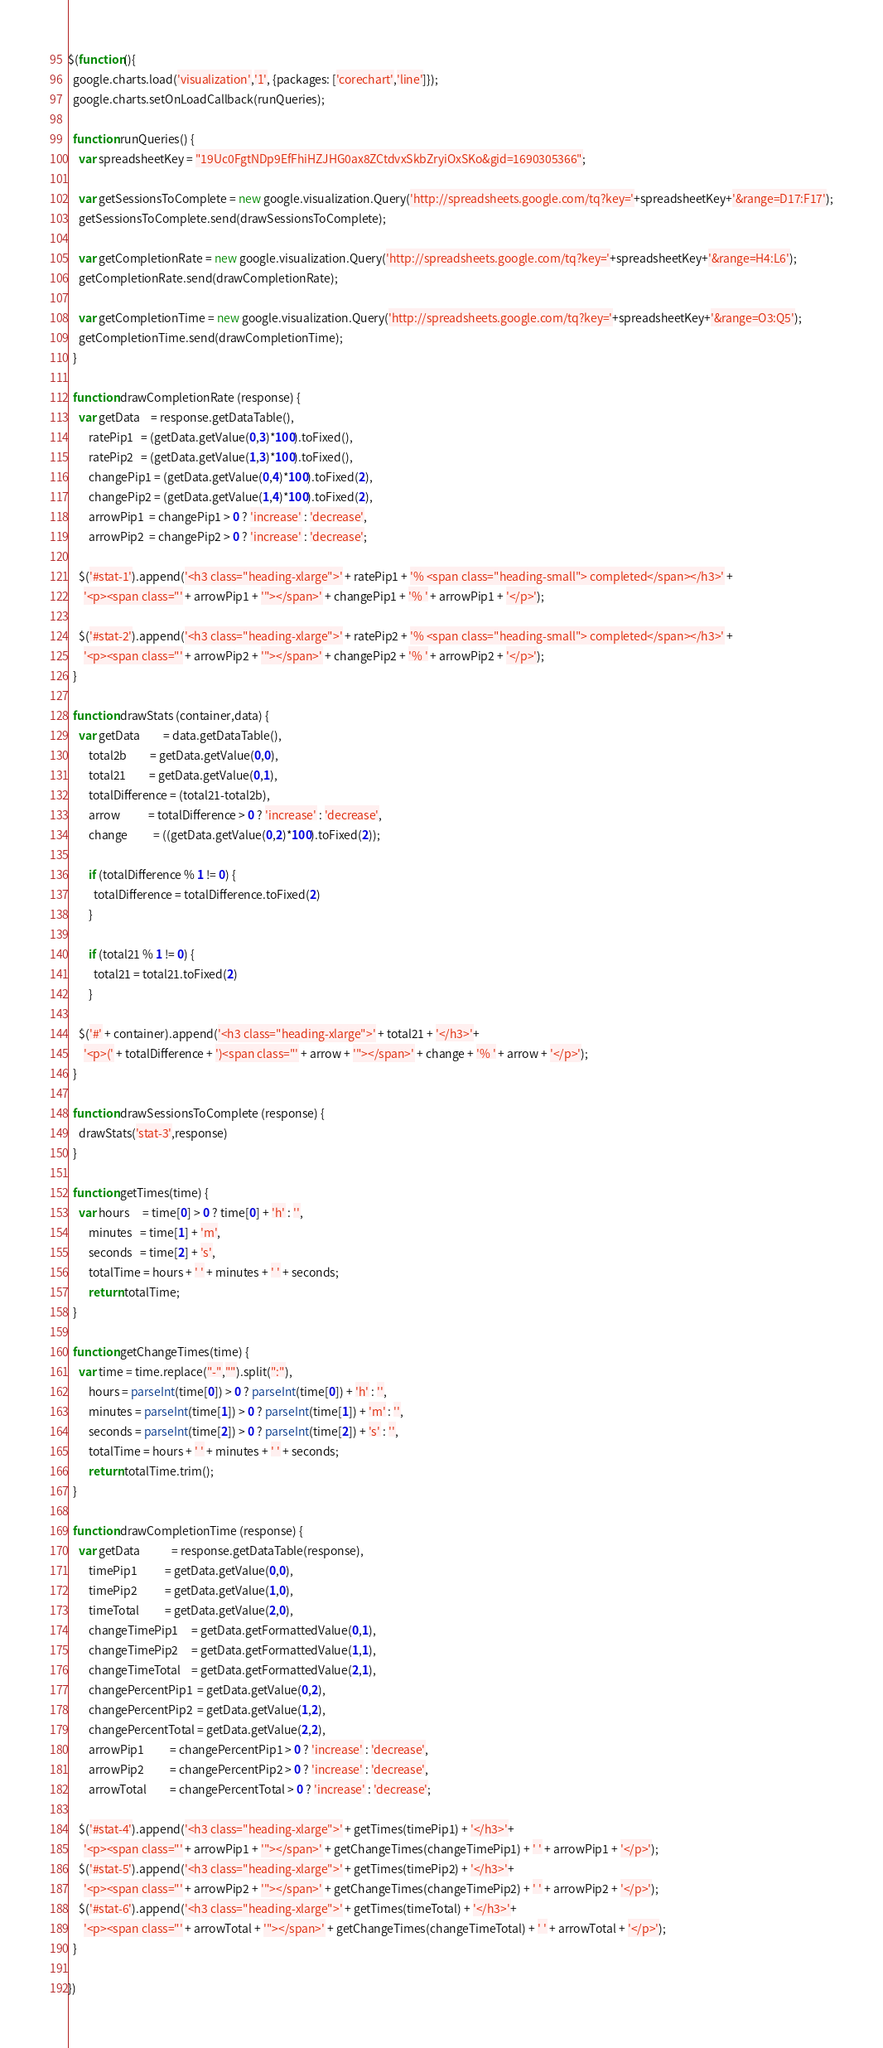<code> <loc_0><loc_0><loc_500><loc_500><_JavaScript_>$(function(){
  google.charts.load('visualization','1', {packages: ['corechart','line']});
  google.charts.setOnLoadCallback(runQueries);

  function runQueries() {
    var spreadsheetKey = "19Uc0FgtNDp9EfFhiHZJHG0ax8ZCtdvxSkbZryiOxSKo&gid=1690305366";

    var getSessionsToComplete = new google.visualization.Query('http://spreadsheets.google.com/tq?key='+spreadsheetKey+'&range=D17:F17');
    getSessionsToComplete.send(drawSessionsToComplete);

    var getCompletionRate = new google.visualization.Query('http://spreadsheets.google.com/tq?key='+spreadsheetKey+'&range=H4:L6');
    getCompletionRate.send(drawCompletionRate);

    var getCompletionTime = new google.visualization.Query('http://spreadsheets.google.com/tq?key='+spreadsheetKey+'&range=O3:Q5');
    getCompletionTime.send(drawCompletionTime);
  }

  function drawCompletionRate (response) {
    var getData    = response.getDataTable(),
        ratePip1   = (getData.getValue(0,3)*100).toFixed(),
        ratePip2   = (getData.getValue(1,3)*100).toFixed(),
        changePip1 = (getData.getValue(0,4)*100).toFixed(2),
        changePip2 = (getData.getValue(1,4)*100).toFixed(2),
        arrowPip1  = changePip1 > 0 ? 'increase' : 'decrease',
        arrowPip2  = changePip2 > 0 ? 'increase' : 'decrease';

    $('#stat-1').append('<h3 class="heading-xlarge">' + ratePip1 + '% <span class="heading-small"> completed</span></h3>' +
      '<p><span class="' + arrowPip1 + '"></span>' + changePip1 + '% ' + arrowPip1 + '</p>');

    $('#stat-2').append('<h3 class="heading-xlarge">' + ratePip2 + '% <span class="heading-small"> completed</span></h3>' +
      '<p><span class="' + arrowPip2 + '"></span>' + changePip2 + '% ' + arrowPip2 + '</p>');
  }

  function drawStats (container,data) {
    var getData         = data.getDataTable(),
        total2b         = getData.getValue(0,0),
        total21         = getData.getValue(0,1),
        totalDifference = (total21-total2b),
        arrow           = totalDifference > 0 ? 'increase' : 'decrease',
        change          = ((getData.getValue(0,2)*100).toFixed(2));

        if (totalDifference % 1 != 0) {
          totalDifference = totalDifference.toFixed(2)
        }

        if (total21 % 1 != 0) {
          total21 = total21.toFixed(2)
        }

    $('#' + container).append('<h3 class="heading-xlarge">' + total21 + '</h3>'+
      '<p>(' + totalDifference + ')<span class="' + arrow + '"></span>' + change + '% ' + arrow + '</p>');
  }

  function drawSessionsToComplete (response) {
    drawStats('stat-3',response)
  }

  function getTimes(time) {
    var hours     = time[0] > 0 ? time[0] + 'h' : '',
        minutes   = time[1] + 'm',
        seconds   = time[2] + 's',
        totalTime = hours + ' ' + minutes + ' ' + seconds;
        return totalTime;
  }

  function getChangeTimes(time) {
    var time = time.replace("-","").split(":"),
        hours = parseInt(time[0]) > 0 ? parseInt(time[0]) + 'h' : '',
        minutes = parseInt(time[1]) > 0 ? parseInt(time[1]) + 'm' : '',
        seconds = parseInt(time[2]) > 0 ? parseInt(time[2]) + 's' : '',
        totalTime = hours + ' ' + minutes + ' ' + seconds;
        return totalTime.trim();
  }

  function drawCompletionTime (response) {
    var getData            = response.getDataTable(response),
        timePip1           = getData.getValue(0,0),
        timePip2           = getData.getValue(1,0),
        timeTotal          = getData.getValue(2,0),
        changeTimePip1     = getData.getFormattedValue(0,1),
        changeTimePip2     = getData.getFormattedValue(1,1),
        changeTimeTotal    = getData.getFormattedValue(2,1),
        changePercentPip1  = getData.getValue(0,2),
        changePercentPip2  = getData.getValue(1,2),
        changePercentTotal = getData.getValue(2,2),
        arrowPip1          = changePercentPip1 > 0 ? 'increase' : 'decrease',
        arrowPip2          = changePercentPip2 > 0 ? 'increase' : 'decrease',
        arrowTotal         = changePercentTotal > 0 ? 'increase' : 'decrease';

    $('#stat-4').append('<h3 class="heading-xlarge">' + getTimes(timePip1) + '</h3>'+
      '<p><span class="' + arrowPip1 + '"></span>' + getChangeTimes(changeTimePip1) + ' ' + arrowPip1 + '</p>');
    $('#stat-5').append('<h3 class="heading-xlarge">' + getTimes(timePip2) + '</h3>'+
      '<p><span class="' + arrowPip2 + '"></span>' + getChangeTimes(changeTimePip2) + ' ' + arrowPip2 + '</p>');
    $('#stat-6').append('<h3 class="heading-xlarge">' + getTimes(timeTotal) + '</h3>'+
      '<p><span class="' + arrowTotal + '"></span>' + getChangeTimes(changeTimeTotal) + ' ' + arrowTotal + '</p>');
  }

})
</code> 